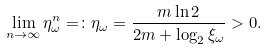<formula> <loc_0><loc_0><loc_500><loc_500>\lim _ { n \to \infty } \eta _ { \omega } ^ { n } = \colon \eta _ { \omega } = \frac { m \ln 2 } { 2 m + \log _ { 2 } \xi _ { \omega } } > 0 .</formula> 